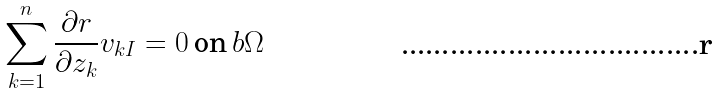<formula> <loc_0><loc_0><loc_500><loc_500>\sum _ { k = 1 } ^ { n } \frac { \partial r } { \partial z _ { k } } v _ { k I } = 0 \, \text {on} \, b \Omega</formula> 